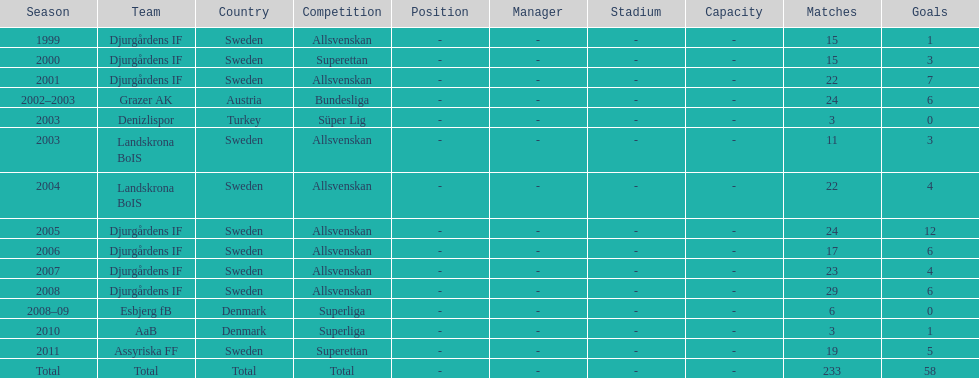What is the total number of matches? 233. 